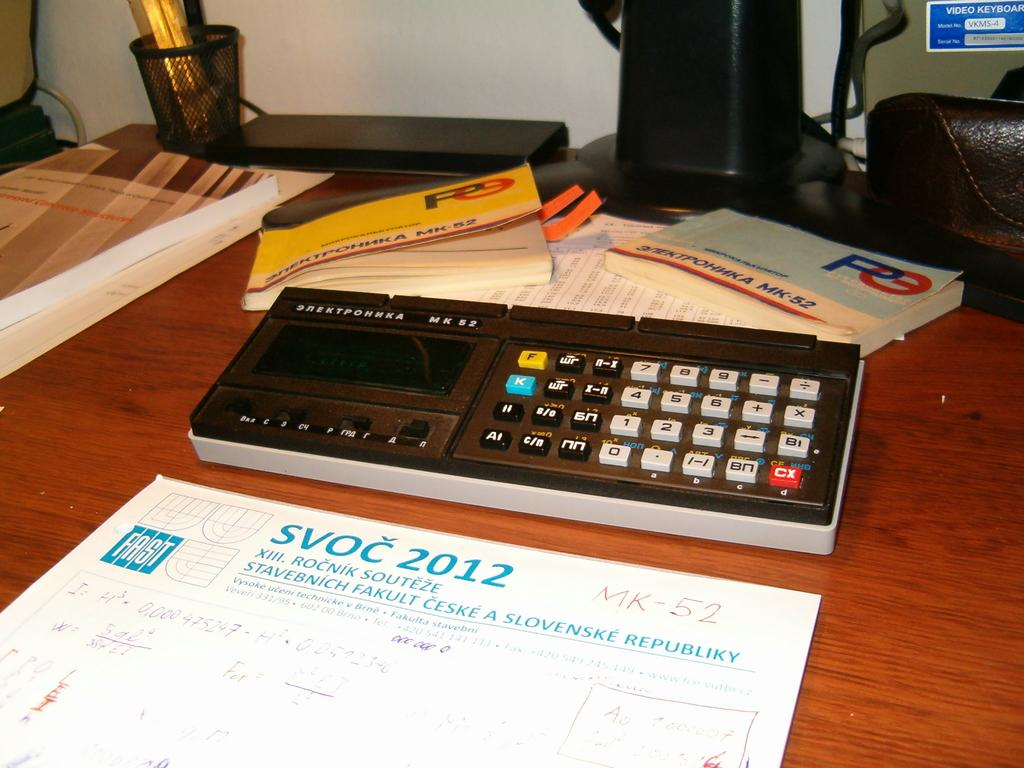<image>
Provide a brief description of the given image. Some math calculations on a sheet of paper with blue SVOC 2012 letters at the top. 